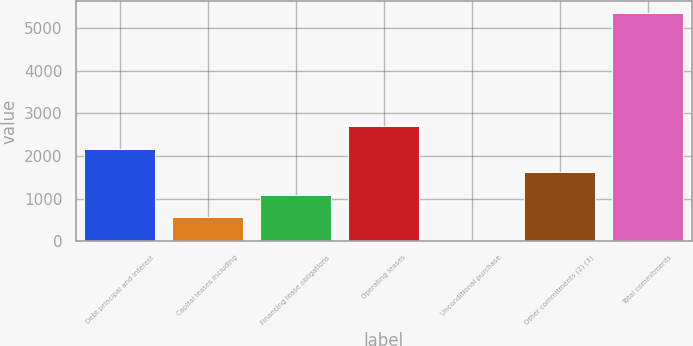Convert chart to OTSL. <chart><loc_0><loc_0><loc_500><loc_500><bar_chart><fcel>Debt principal and interest<fcel>Capital leases including<fcel>Financing lease obligations<fcel>Operating leases<fcel>Unconditional purchase<fcel>Other commitments (2) (3)<fcel>Total commitments<nl><fcel>2159.4<fcel>560.1<fcel>1093.2<fcel>2692.5<fcel>27<fcel>1626.3<fcel>5358<nl></chart> 